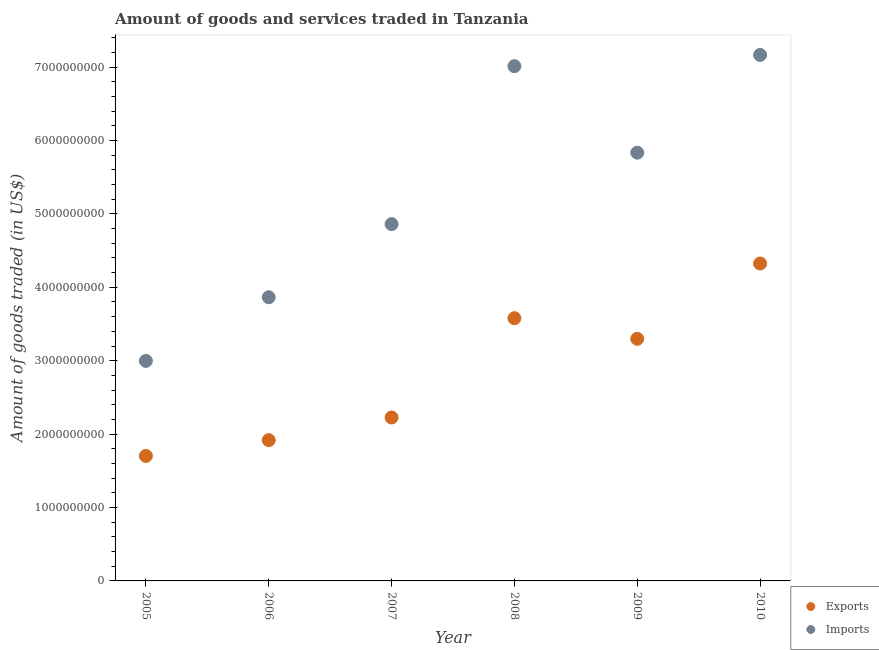What is the amount of goods imported in 2005?
Give a very brief answer. 3.00e+09. Across all years, what is the maximum amount of goods exported?
Offer a very short reply. 4.32e+09. Across all years, what is the minimum amount of goods imported?
Offer a very short reply. 3.00e+09. In which year was the amount of goods imported maximum?
Give a very brief answer. 2010. What is the total amount of goods exported in the graph?
Your answer should be very brief. 1.70e+1. What is the difference between the amount of goods exported in 2006 and that in 2008?
Give a very brief answer. -1.66e+09. What is the difference between the amount of goods imported in 2007 and the amount of goods exported in 2005?
Keep it short and to the point. 3.16e+09. What is the average amount of goods imported per year?
Offer a very short reply. 5.29e+09. In the year 2009, what is the difference between the amount of goods imported and amount of goods exported?
Make the answer very short. 2.54e+09. In how many years, is the amount of goods imported greater than 5200000000 US$?
Your answer should be very brief. 3. What is the ratio of the amount of goods imported in 2005 to that in 2010?
Ensure brevity in your answer.  0.42. Is the amount of goods imported in 2009 less than that in 2010?
Make the answer very short. Yes. Is the difference between the amount of goods imported in 2005 and 2010 greater than the difference between the amount of goods exported in 2005 and 2010?
Provide a succinct answer. No. What is the difference between the highest and the second highest amount of goods imported?
Provide a succinct answer. 1.53e+08. What is the difference between the highest and the lowest amount of goods imported?
Offer a very short reply. 4.17e+09. Is the sum of the amount of goods imported in 2006 and 2007 greater than the maximum amount of goods exported across all years?
Give a very brief answer. Yes. Does the amount of goods exported monotonically increase over the years?
Offer a very short reply. No. Is the amount of goods imported strictly greater than the amount of goods exported over the years?
Offer a terse response. Yes. Is the amount of goods imported strictly less than the amount of goods exported over the years?
Give a very brief answer. No. How many dotlines are there?
Offer a very short reply. 2. How many years are there in the graph?
Provide a succinct answer. 6. What is the title of the graph?
Provide a short and direct response. Amount of goods and services traded in Tanzania. Does "Lower secondary rate" appear as one of the legend labels in the graph?
Ensure brevity in your answer.  No. What is the label or title of the X-axis?
Ensure brevity in your answer.  Year. What is the label or title of the Y-axis?
Provide a short and direct response. Amount of goods traded (in US$). What is the Amount of goods traded (in US$) in Exports in 2005?
Your answer should be very brief. 1.70e+09. What is the Amount of goods traded (in US$) in Imports in 2005?
Ensure brevity in your answer.  3.00e+09. What is the Amount of goods traded (in US$) of Exports in 2006?
Provide a succinct answer. 1.92e+09. What is the Amount of goods traded (in US$) of Imports in 2006?
Give a very brief answer. 3.86e+09. What is the Amount of goods traded (in US$) of Exports in 2007?
Give a very brief answer. 2.23e+09. What is the Amount of goods traded (in US$) of Imports in 2007?
Ensure brevity in your answer.  4.86e+09. What is the Amount of goods traded (in US$) of Exports in 2008?
Give a very brief answer. 3.58e+09. What is the Amount of goods traded (in US$) in Imports in 2008?
Your answer should be compact. 7.01e+09. What is the Amount of goods traded (in US$) of Exports in 2009?
Offer a very short reply. 3.30e+09. What is the Amount of goods traded (in US$) in Imports in 2009?
Your response must be concise. 5.83e+09. What is the Amount of goods traded (in US$) in Exports in 2010?
Provide a short and direct response. 4.32e+09. What is the Amount of goods traded (in US$) of Imports in 2010?
Provide a succinct answer. 7.17e+09. Across all years, what is the maximum Amount of goods traded (in US$) of Exports?
Give a very brief answer. 4.32e+09. Across all years, what is the maximum Amount of goods traded (in US$) in Imports?
Ensure brevity in your answer.  7.17e+09. Across all years, what is the minimum Amount of goods traded (in US$) in Exports?
Offer a very short reply. 1.70e+09. Across all years, what is the minimum Amount of goods traded (in US$) of Imports?
Offer a very short reply. 3.00e+09. What is the total Amount of goods traded (in US$) of Exports in the graph?
Ensure brevity in your answer.  1.70e+1. What is the total Amount of goods traded (in US$) in Imports in the graph?
Ensure brevity in your answer.  3.17e+1. What is the difference between the Amount of goods traded (in US$) in Exports in 2005 and that in 2006?
Make the answer very short. -2.15e+08. What is the difference between the Amount of goods traded (in US$) in Imports in 2005 and that in 2006?
Offer a very short reply. -8.67e+08. What is the difference between the Amount of goods traded (in US$) in Exports in 2005 and that in 2007?
Make the answer very short. -5.24e+08. What is the difference between the Amount of goods traded (in US$) in Imports in 2005 and that in 2007?
Provide a short and direct response. -1.86e+09. What is the difference between the Amount of goods traded (in US$) of Exports in 2005 and that in 2008?
Ensure brevity in your answer.  -1.88e+09. What is the difference between the Amount of goods traded (in US$) of Imports in 2005 and that in 2008?
Give a very brief answer. -4.01e+09. What is the difference between the Amount of goods traded (in US$) of Exports in 2005 and that in 2009?
Provide a short and direct response. -1.60e+09. What is the difference between the Amount of goods traded (in US$) of Imports in 2005 and that in 2009?
Provide a short and direct response. -2.84e+09. What is the difference between the Amount of goods traded (in US$) of Exports in 2005 and that in 2010?
Your response must be concise. -2.62e+09. What is the difference between the Amount of goods traded (in US$) in Imports in 2005 and that in 2010?
Your answer should be compact. -4.17e+09. What is the difference between the Amount of goods traded (in US$) of Exports in 2006 and that in 2007?
Make the answer very short. -3.09e+08. What is the difference between the Amount of goods traded (in US$) of Imports in 2006 and that in 2007?
Your answer should be very brief. -9.97e+08. What is the difference between the Amount of goods traded (in US$) of Exports in 2006 and that in 2008?
Offer a very short reply. -1.66e+09. What is the difference between the Amount of goods traded (in US$) of Imports in 2006 and that in 2008?
Provide a short and direct response. -3.15e+09. What is the difference between the Amount of goods traded (in US$) in Exports in 2006 and that in 2009?
Your answer should be compact. -1.38e+09. What is the difference between the Amount of goods traded (in US$) of Imports in 2006 and that in 2009?
Offer a very short reply. -1.97e+09. What is the difference between the Amount of goods traded (in US$) of Exports in 2006 and that in 2010?
Your answer should be compact. -2.41e+09. What is the difference between the Amount of goods traded (in US$) of Imports in 2006 and that in 2010?
Your answer should be very brief. -3.30e+09. What is the difference between the Amount of goods traded (in US$) in Exports in 2007 and that in 2008?
Your answer should be very brief. -1.35e+09. What is the difference between the Amount of goods traded (in US$) in Imports in 2007 and that in 2008?
Offer a terse response. -2.15e+09. What is the difference between the Amount of goods traded (in US$) in Exports in 2007 and that in 2009?
Your answer should be compact. -1.07e+09. What is the difference between the Amount of goods traded (in US$) in Imports in 2007 and that in 2009?
Provide a succinct answer. -9.74e+08. What is the difference between the Amount of goods traded (in US$) of Exports in 2007 and that in 2010?
Provide a succinct answer. -2.10e+09. What is the difference between the Amount of goods traded (in US$) of Imports in 2007 and that in 2010?
Your response must be concise. -2.30e+09. What is the difference between the Amount of goods traded (in US$) in Exports in 2008 and that in 2009?
Offer a terse response. 2.81e+08. What is the difference between the Amount of goods traded (in US$) in Imports in 2008 and that in 2009?
Your response must be concise. 1.18e+09. What is the difference between the Amount of goods traded (in US$) of Exports in 2008 and that in 2010?
Ensure brevity in your answer.  -7.45e+08. What is the difference between the Amount of goods traded (in US$) in Imports in 2008 and that in 2010?
Ensure brevity in your answer.  -1.53e+08. What is the difference between the Amount of goods traded (in US$) of Exports in 2009 and that in 2010?
Ensure brevity in your answer.  -1.03e+09. What is the difference between the Amount of goods traded (in US$) in Imports in 2009 and that in 2010?
Keep it short and to the point. -1.33e+09. What is the difference between the Amount of goods traded (in US$) of Exports in 2005 and the Amount of goods traded (in US$) of Imports in 2006?
Provide a succinct answer. -2.16e+09. What is the difference between the Amount of goods traded (in US$) of Exports in 2005 and the Amount of goods traded (in US$) of Imports in 2007?
Your answer should be very brief. -3.16e+09. What is the difference between the Amount of goods traded (in US$) in Exports in 2005 and the Amount of goods traded (in US$) in Imports in 2008?
Offer a very short reply. -5.31e+09. What is the difference between the Amount of goods traded (in US$) in Exports in 2005 and the Amount of goods traded (in US$) in Imports in 2009?
Your answer should be compact. -4.13e+09. What is the difference between the Amount of goods traded (in US$) of Exports in 2005 and the Amount of goods traded (in US$) of Imports in 2010?
Your answer should be very brief. -5.46e+09. What is the difference between the Amount of goods traded (in US$) of Exports in 2006 and the Amount of goods traded (in US$) of Imports in 2007?
Offer a terse response. -2.94e+09. What is the difference between the Amount of goods traded (in US$) in Exports in 2006 and the Amount of goods traded (in US$) in Imports in 2008?
Offer a terse response. -5.09e+09. What is the difference between the Amount of goods traded (in US$) in Exports in 2006 and the Amount of goods traded (in US$) in Imports in 2009?
Make the answer very short. -3.92e+09. What is the difference between the Amount of goods traded (in US$) of Exports in 2006 and the Amount of goods traded (in US$) of Imports in 2010?
Keep it short and to the point. -5.25e+09. What is the difference between the Amount of goods traded (in US$) in Exports in 2007 and the Amount of goods traded (in US$) in Imports in 2008?
Provide a succinct answer. -4.79e+09. What is the difference between the Amount of goods traded (in US$) in Exports in 2007 and the Amount of goods traded (in US$) in Imports in 2009?
Make the answer very short. -3.61e+09. What is the difference between the Amount of goods traded (in US$) in Exports in 2007 and the Amount of goods traded (in US$) in Imports in 2010?
Your answer should be compact. -4.94e+09. What is the difference between the Amount of goods traded (in US$) in Exports in 2008 and the Amount of goods traded (in US$) in Imports in 2009?
Provide a short and direct response. -2.26e+09. What is the difference between the Amount of goods traded (in US$) of Exports in 2008 and the Amount of goods traded (in US$) of Imports in 2010?
Give a very brief answer. -3.59e+09. What is the difference between the Amount of goods traded (in US$) of Exports in 2009 and the Amount of goods traded (in US$) of Imports in 2010?
Offer a very short reply. -3.87e+09. What is the average Amount of goods traded (in US$) of Exports per year?
Offer a very short reply. 2.84e+09. What is the average Amount of goods traded (in US$) in Imports per year?
Ensure brevity in your answer.  5.29e+09. In the year 2005, what is the difference between the Amount of goods traded (in US$) in Exports and Amount of goods traded (in US$) in Imports?
Keep it short and to the point. -1.30e+09. In the year 2006, what is the difference between the Amount of goods traded (in US$) of Exports and Amount of goods traded (in US$) of Imports?
Keep it short and to the point. -1.95e+09. In the year 2007, what is the difference between the Amount of goods traded (in US$) of Exports and Amount of goods traded (in US$) of Imports?
Provide a succinct answer. -2.63e+09. In the year 2008, what is the difference between the Amount of goods traded (in US$) of Exports and Amount of goods traded (in US$) of Imports?
Provide a short and direct response. -3.43e+09. In the year 2009, what is the difference between the Amount of goods traded (in US$) in Exports and Amount of goods traded (in US$) in Imports?
Keep it short and to the point. -2.54e+09. In the year 2010, what is the difference between the Amount of goods traded (in US$) of Exports and Amount of goods traded (in US$) of Imports?
Offer a very short reply. -2.84e+09. What is the ratio of the Amount of goods traded (in US$) in Exports in 2005 to that in 2006?
Keep it short and to the point. 0.89. What is the ratio of the Amount of goods traded (in US$) in Imports in 2005 to that in 2006?
Provide a succinct answer. 0.78. What is the ratio of the Amount of goods traded (in US$) in Exports in 2005 to that in 2007?
Give a very brief answer. 0.76. What is the ratio of the Amount of goods traded (in US$) in Imports in 2005 to that in 2007?
Ensure brevity in your answer.  0.62. What is the ratio of the Amount of goods traded (in US$) in Exports in 2005 to that in 2008?
Make the answer very short. 0.48. What is the ratio of the Amount of goods traded (in US$) in Imports in 2005 to that in 2008?
Offer a very short reply. 0.43. What is the ratio of the Amount of goods traded (in US$) in Exports in 2005 to that in 2009?
Keep it short and to the point. 0.52. What is the ratio of the Amount of goods traded (in US$) of Imports in 2005 to that in 2009?
Offer a terse response. 0.51. What is the ratio of the Amount of goods traded (in US$) of Exports in 2005 to that in 2010?
Provide a short and direct response. 0.39. What is the ratio of the Amount of goods traded (in US$) of Imports in 2005 to that in 2010?
Keep it short and to the point. 0.42. What is the ratio of the Amount of goods traded (in US$) in Exports in 2006 to that in 2007?
Offer a terse response. 0.86. What is the ratio of the Amount of goods traded (in US$) of Imports in 2006 to that in 2007?
Your response must be concise. 0.8. What is the ratio of the Amount of goods traded (in US$) in Exports in 2006 to that in 2008?
Provide a succinct answer. 0.54. What is the ratio of the Amount of goods traded (in US$) in Imports in 2006 to that in 2008?
Make the answer very short. 0.55. What is the ratio of the Amount of goods traded (in US$) in Exports in 2006 to that in 2009?
Your response must be concise. 0.58. What is the ratio of the Amount of goods traded (in US$) in Imports in 2006 to that in 2009?
Your answer should be compact. 0.66. What is the ratio of the Amount of goods traded (in US$) of Exports in 2006 to that in 2010?
Offer a very short reply. 0.44. What is the ratio of the Amount of goods traded (in US$) in Imports in 2006 to that in 2010?
Your answer should be compact. 0.54. What is the ratio of the Amount of goods traded (in US$) of Exports in 2007 to that in 2008?
Keep it short and to the point. 0.62. What is the ratio of the Amount of goods traded (in US$) of Imports in 2007 to that in 2008?
Your answer should be compact. 0.69. What is the ratio of the Amount of goods traded (in US$) of Exports in 2007 to that in 2009?
Your answer should be compact. 0.68. What is the ratio of the Amount of goods traded (in US$) in Imports in 2007 to that in 2009?
Provide a short and direct response. 0.83. What is the ratio of the Amount of goods traded (in US$) in Exports in 2007 to that in 2010?
Ensure brevity in your answer.  0.51. What is the ratio of the Amount of goods traded (in US$) in Imports in 2007 to that in 2010?
Your answer should be very brief. 0.68. What is the ratio of the Amount of goods traded (in US$) in Exports in 2008 to that in 2009?
Provide a succinct answer. 1.09. What is the ratio of the Amount of goods traded (in US$) of Imports in 2008 to that in 2009?
Provide a short and direct response. 1.2. What is the ratio of the Amount of goods traded (in US$) of Exports in 2008 to that in 2010?
Your answer should be compact. 0.83. What is the ratio of the Amount of goods traded (in US$) of Imports in 2008 to that in 2010?
Your answer should be very brief. 0.98. What is the ratio of the Amount of goods traded (in US$) in Exports in 2009 to that in 2010?
Your answer should be compact. 0.76. What is the ratio of the Amount of goods traded (in US$) of Imports in 2009 to that in 2010?
Make the answer very short. 0.81. What is the difference between the highest and the second highest Amount of goods traded (in US$) of Exports?
Your answer should be very brief. 7.45e+08. What is the difference between the highest and the second highest Amount of goods traded (in US$) in Imports?
Make the answer very short. 1.53e+08. What is the difference between the highest and the lowest Amount of goods traded (in US$) of Exports?
Keep it short and to the point. 2.62e+09. What is the difference between the highest and the lowest Amount of goods traded (in US$) of Imports?
Give a very brief answer. 4.17e+09. 